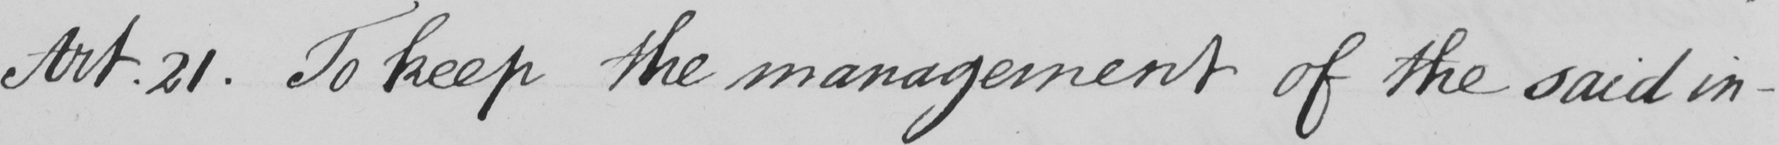Please provide the text content of this handwritten line. Art . 21 . To keep the management of the said in- 